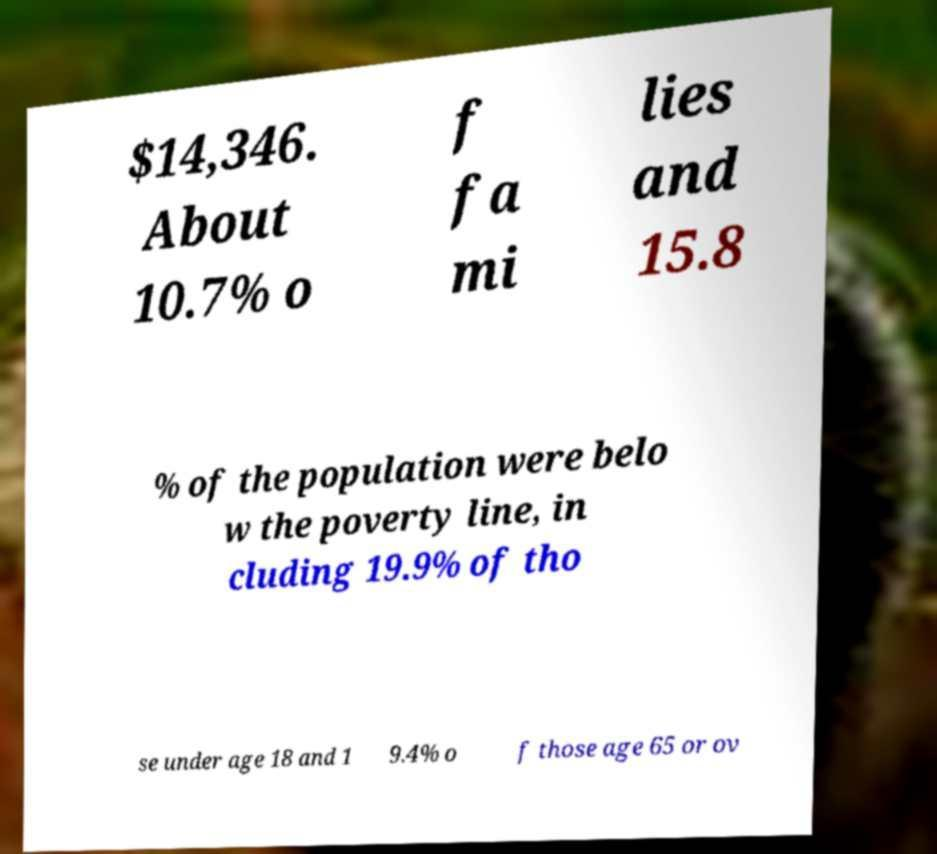What messages or text are displayed in this image? I need them in a readable, typed format. $14,346. About 10.7% o f fa mi lies and 15.8 % of the population were belo w the poverty line, in cluding 19.9% of tho se under age 18 and 1 9.4% o f those age 65 or ov 